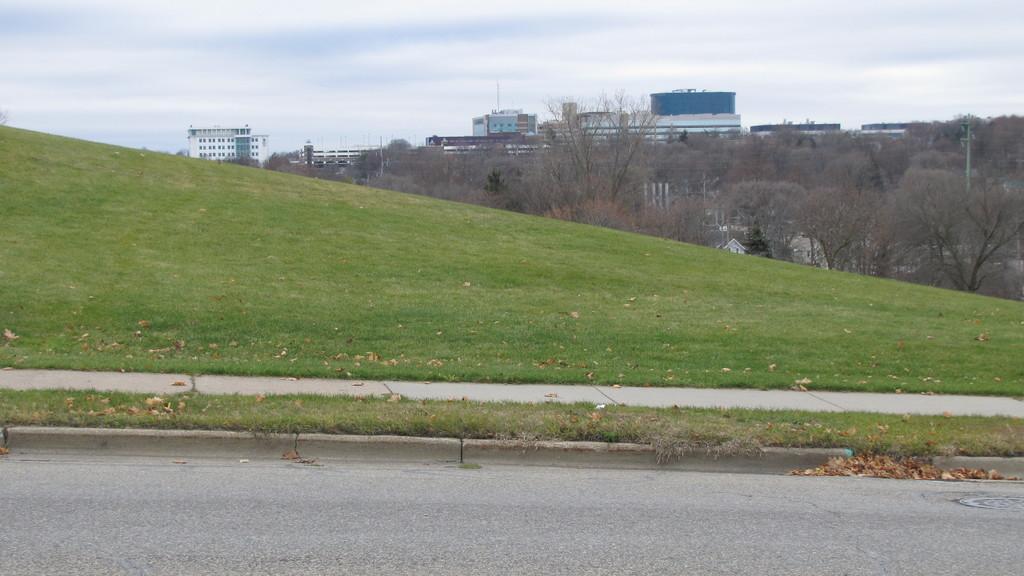Describe this image in one or two sentences. At the bottom of the picture, we see the road. Beside that, we see grass and dried leaves. There are many trees and buildings in the background. At the top of the picture, we see the sky and this picture is clicked outside the city. 